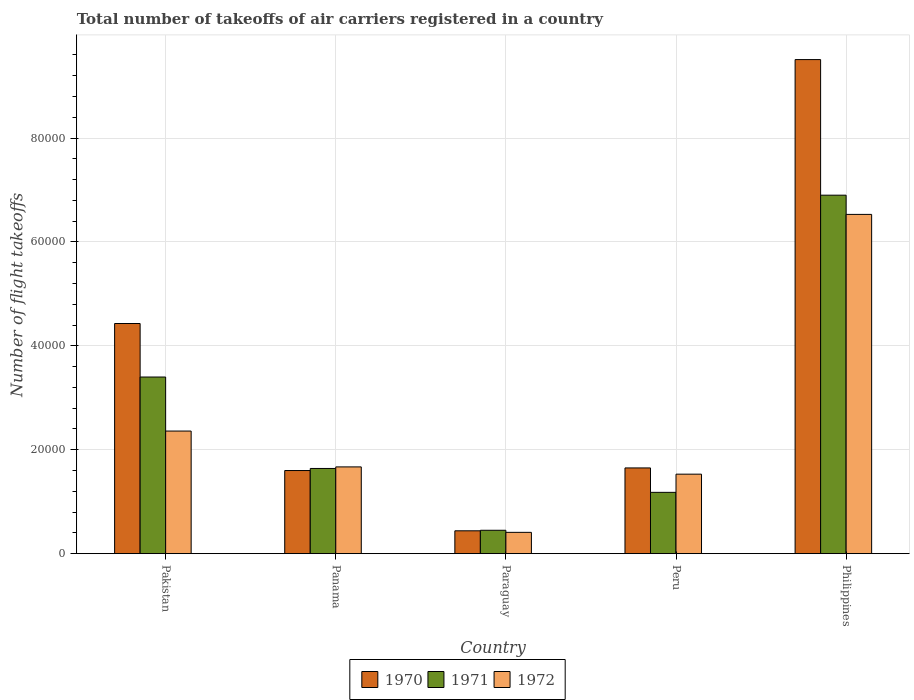How many different coloured bars are there?
Give a very brief answer. 3. How many groups of bars are there?
Your answer should be very brief. 5. Are the number of bars per tick equal to the number of legend labels?
Provide a succinct answer. Yes. How many bars are there on the 3rd tick from the left?
Give a very brief answer. 3. What is the label of the 4th group of bars from the left?
Make the answer very short. Peru. What is the total number of flight takeoffs in 1970 in Paraguay?
Give a very brief answer. 4400. Across all countries, what is the maximum total number of flight takeoffs in 1970?
Your answer should be compact. 9.51e+04. Across all countries, what is the minimum total number of flight takeoffs in 1972?
Make the answer very short. 4100. In which country was the total number of flight takeoffs in 1972 minimum?
Offer a very short reply. Paraguay. What is the total total number of flight takeoffs in 1971 in the graph?
Offer a terse response. 1.36e+05. What is the difference between the total number of flight takeoffs in 1972 in Paraguay and that in Philippines?
Make the answer very short. -6.12e+04. What is the difference between the total number of flight takeoffs in 1970 in Paraguay and the total number of flight takeoffs in 1971 in Pakistan?
Provide a succinct answer. -2.96e+04. What is the average total number of flight takeoffs in 1971 per country?
Keep it short and to the point. 2.71e+04. What is the difference between the total number of flight takeoffs of/in 1971 and total number of flight takeoffs of/in 1970 in Philippines?
Provide a short and direct response. -2.61e+04. In how many countries, is the total number of flight takeoffs in 1970 greater than 8000?
Provide a succinct answer. 4. What is the ratio of the total number of flight takeoffs in 1971 in Peru to that in Philippines?
Provide a succinct answer. 0.17. Is the total number of flight takeoffs in 1971 in Paraguay less than that in Peru?
Offer a terse response. Yes. Is the difference between the total number of flight takeoffs in 1971 in Panama and Peru greater than the difference between the total number of flight takeoffs in 1970 in Panama and Peru?
Give a very brief answer. Yes. What is the difference between the highest and the second highest total number of flight takeoffs in 1970?
Provide a short and direct response. -7.86e+04. What is the difference between the highest and the lowest total number of flight takeoffs in 1972?
Your response must be concise. 6.12e+04. In how many countries, is the total number of flight takeoffs in 1972 greater than the average total number of flight takeoffs in 1972 taken over all countries?
Provide a succinct answer. 1. How many bars are there?
Your answer should be compact. 15. Are all the bars in the graph horizontal?
Your answer should be very brief. No. What is the difference between two consecutive major ticks on the Y-axis?
Keep it short and to the point. 2.00e+04. Are the values on the major ticks of Y-axis written in scientific E-notation?
Offer a terse response. No. Does the graph contain grids?
Your response must be concise. Yes. How are the legend labels stacked?
Keep it short and to the point. Horizontal. What is the title of the graph?
Give a very brief answer. Total number of takeoffs of air carriers registered in a country. What is the label or title of the X-axis?
Ensure brevity in your answer.  Country. What is the label or title of the Y-axis?
Your response must be concise. Number of flight takeoffs. What is the Number of flight takeoffs in 1970 in Pakistan?
Your answer should be compact. 4.43e+04. What is the Number of flight takeoffs of 1971 in Pakistan?
Make the answer very short. 3.40e+04. What is the Number of flight takeoffs in 1972 in Pakistan?
Provide a succinct answer. 2.36e+04. What is the Number of flight takeoffs in 1970 in Panama?
Keep it short and to the point. 1.60e+04. What is the Number of flight takeoffs in 1971 in Panama?
Provide a short and direct response. 1.64e+04. What is the Number of flight takeoffs of 1972 in Panama?
Your answer should be compact. 1.67e+04. What is the Number of flight takeoffs in 1970 in Paraguay?
Offer a terse response. 4400. What is the Number of flight takeoffs in 1971 in Paraguay?
Offer a very short reply. 4500. What is the Number of flight takeoffs in 1972 in Paraguay?
Give a very brief answer. 4100. What is the Number of flight takeoffs in 1970 in Peru?
Keep it short and to the point. 1.65e+04. What is the Number of flight takeoffs of 1971 in Peru?
Give a very brief answer. 1.18e+04. What is the Number of flight takeoffs in 1972 in Peru?
Ensure brevity in your answer.  1.53e+04. What is the Number of flight takeoffs in 1970 in Philippines?
Your response must be concise. 9.51e+04. What is the Number of flight takeoffs of 1971 in Philippines?
Offer a very short reply. 6.90e+04. What is the Number of flight takeoffs of 1972 in Philippines?
Your answer should be compact. 6.53e+04. Across all countries, what is the maximum Number of flight takeoffs of 1970?
Offer a very short reply. 9.51e+04. Across all countries, what is the maximum Number of flight takeoffs of 1971?
Ensure brevity in your answer.  6.90e+04. Across all countries, what is the maximum Number of flight takeoffs in 1972?
Provide a succinct answer. 6.53e+04. Across all countries, what is the minimum Number of flight takeoffs of 1970?
Your answer should be compact. 4400. Across all countries, what is the minimum Number of flight takeoffs of 1971?
Your answer should be very brief. 4500. Across all countries, what is the minimum Number of flight takeoffs in 1972?
Give a very brief answer. 4100. What is the total Number of flight takeoffs of 1970 in the graph?
Provide a short and direct response. 1.76e+05. What is the total Number of flight takeoffs in 1971 in the graph?
Give a very brief answer. 1.36e+05. What is the total Number of flight takeoffs of 1972 in the graph?
Provide a succinct answer. 1.25e+05. What is the difference between the Number of flight takeoffs of 1970 in Pakistan and that in Panama?
Ensure brevity in your answer.  2.83e+04. What is the difference between the Number of flight takeoffs in 1971 in Pakistan and that in Panama?
Offer a very short reply. 1.76e+04. What is the difference between the Number of flight takeoffs in 1972 in Pakistan and that in Panama?
Your response must be concise. 6900. What is the difference between the Number of flight takeoffs of 1970 in Pakistan and that in Paraguay?
Your answer should be compact. 3.99e+04. What is the difference between the Number of flight takeoffs of 1971 in Pakistan and that in Paraguay?
Provide a short and direct response. 2.95e+04. What is the difference between the Number of flight takeoffs in 1972 in Pakistan and that in Paraguay?
Your answer should be compact. 1.95e+04. What is the difference between the Number of flight takeoffs of 1970 in Pakistan and that in Peru?
Offer a terse response. 2.78e+04. What is the difference between the Number of flight takeoffs in 1971 in Pakistan and that in Peru?
Provide a short and direct response. 2.22e+04. What is the difference between the Number of flight takeoffs of 1972 in Pakistan and that in Peru?
Offer a terse response. 8300. What is the difference between the Number of flight takeoffs of 1970 in Pakistan and that in Philippines?
Your answer should be compact. -5.08e+04. What is the difference between the Number of flight takeoffs of 1971 in Pakistan and that in Philippines?
Provide a succinct answer. -3.50e+04. What is the difference between the Number of flight takeoffs in 1972 in Pakistan and that in Philippines?
Offer a very short reply. -4.17e+04. What is the difference between the Number of flight takeoffs in 1970 in Panama and that in Paraguay?
Your answer should be compact. 1.16e+04. What is the difference between the Number of flight takeoffs in 1971 in Panama and that in Paraguay?
Provide a succinct answer. 1.19e+04. What is the difference between the Number of flight takeoffs of 1972 in Panama and that in Paraguay?
Make the answer very short. 1.26e+04. What is the difference between the Number of flight takeoffs of 1970 in Panama and that in Peru?
Provide a succinct answer. -500. What is the difference between the Number of flight takeoffs in 1971 in Panama and that in Peru?
Keep it short and to the point. 4600. What is the difference between the Number of flight takeoffs in 1972 in Panama and that in Peru?
Your answer should be very brief. 1400. What is the difference between the Number of flight takeoffs in 1970 in Panama and that in Philippines?
Give a very brief answer. -7.91e+04. What is the difference between the Number of flight takeoffs in 1971 in Panama and that in Philippines?
Your answer should be very brief. -5.26e+04. What is the difference between the Number of flight takeoffs in 1972 in Panama and that in Philippines?
Ensure brevity in your answer.  -4.86e+04. What is the difference between the Number of flight takeoffs in 1970 in Paraguay and that in Peru?
Make the answer very short. -1.21e+04. What is the difference between the Number of flight takeoffs of 1971 in Paraguay and that in Peru?
Provide a short and direct response. -7300. What is the difference between the Number of flight takeoffs of 1972 in Paraguay and that in Peru?
Keep it short and to the point. -1.12e+04. What is the difference between the Number of flight takeoffs in 1970 in Paraguay and that in Philippines?
Give a very brief answer. -9.07e+04. What is the difference between the Number of flight takeoffs in 1971 in Paraguay and that in Philippines?
Give a very brief answer. -6.45e+04. What is the difference between the Number of flight takeoffs of 1972 in Paraguay and that in Philippines?
Offer a terse response. -6.12e+04. What is the difference between the Number of flight takeoffs in 1970 in Peru and that in Philippines?
Your answer should be very brief. -7.86e+04. What is the difference between the Number of flight takeoffs in 1971 in Peru and that in Philippines?
Your answer should be compact. -5.72e+04. What is the difference between the Number of flight takeoffs in 1970 in Pakistan and the Number of flight takeoffs in 1971 in Panama?
Keep it short and to the point. 2.79e+04. What is the difference between the Number of flight takeoffs in 1970 in Pakistan and the Number of flight takeoffs in 1972 in Panama?
Make the answer very short. 2.76e+04. What is the difference between the Number of flight takeoffs of 1971 in Pakistan and the Number of flight takeoffs of 1972 in Panama?
Your answer should be very brief. 1.73e+04. What is the difference between the Number of flight takeoffs of 1970 in Pakistan and the Number of flight takeoffs of 1971 in Paraguay?
Offer a terse response. 3.98e+04. What is the difference between the Number of flight takeoffs of 1970 in Pakistan and the Number of flight takeoffs of 1972 in Paraguay?
Ensure brevity in your answer.  4.02e+04. What is the difference between the Number of flight takeoffs in 1971 in Pakistan and the Number of flight takeoffs in 1972 in Paraguay?
Your response must be concise. 2.99e+04. What is the difference between the Number of flight takeoffs of 1970 in Pakistan and the Number of flight takeoffs of 1971 in Peru?
Your answer should be compact. 3.25e+04. What is the difference between the Number of flight takeoffs of 1970 in Pakistan and the Number of flight takeoffs of 1972 in Peru?
Make the answer very short. 2.90e+04. What is the difference between the Number of flight takeoffs of 1971 in Pakistan and the Number of flight takeoffs of 1972 in Peru?
Keep it short and to the point. 1.87e+04. What is the difference between the Number of flight takeoffs in 1970 in Pakistan and the Number of flight takeoffs in 1971 in Philippines?
Give a very brief answer. -2.47e+04. What is the difference between the Number of flight takeoffs in 1970 in Pakistan and the Number of flight takeoffs in 1972 in Philippines?
Provide a short and direct response. -2.10e+04. What is the difference between the Number of flight takeoffs in 1971 in Pakistan and the Number of flight takeoffs in 1972 in Philippines?
Provide a short and direct response. -3.13e+04. What is the difference between the Number of flight takeoffs of 1970 in Panama and the Number of flight takeoffs of 1971 in Paraguay?
Give a very brief answer. 1.15e+04. What is the difference between the Number of flight takeoffs in 1970 in Panama and the Number of flight takeoffs in 1972 in Paraguay?
Provide a short and direct response. 1.19e+04. What is the difference between the Number of flight takeoffs of 1971 in Panama and the Number of flight takeoffs of 1972 in Paraguay?
Give a very brief answer. 1.23e+04. What is the difference between the Number of flight takeoffs in 1970 in Panama and the Number of flight takeoffs in 1971 in Peru?
Make the answer very short. 4200. What is the difference between the Number of flight takeoffs in 1970 in Panama and the Number of flight takeoffs in 1972 in Peru?
Your response must be concise. 700. What is the difference between the Number of flight takeoffs of 1971 in Panama and the Number of flight takeoffs of 1972 in Peru?
Offer a very short reply. 1100. What is the difference between the Number of flight takeoffs in 1970 in Panama and the Number of flight takeoffs in 1971 in Philippines?
Your answer should be compact. -5.30e+04. What is the difference between the Number of flight takeoffs of 1970 in Panama and the Number of flight takeoffs of 1972 in Philippines?
Your response must be concise. -4.93e+04. What is the difference between the Number of flight takeoffs in 1971 in Panama and the Number of flight takeoffs in 1972 in Philippines?
Offer a very short reply. -4.89e+04. What is the difference between the Number of flight takeoffs in 1970 in Paraguay and the Number of flight takeoffs in 1971 in Peru?
Make the answer very short. -7400. What is the difference between the Number of flight takeoffs in 1970 in Paraguay and the Number of flight takeoffs in 1972 in Peru?
Provide a short and direct response. -1.09e+04. What is the difference between the Number of flight takeoffs of 1971 in Paraguay and the Number of flight takeoffs of 1972 in Peru?
Your answer should be compact. -1.08e+04. What is the difference between the Number of flight takeoffs of 1970 in Paraguay and the Number of flight takeoffs of 1971 in Philippines?
Offer a very short reply. -6.46e+04. What is the difference between the Number of flight takeoffs of 1970 in Paraguay and the Number of flight takeoffs of 1972 in Philippines?
Provide a short and direct response. -6.09e+04. What is the difference between the Number of flight takeoffs in 1971 in Paraguay and the Number of flight takeoffs in 1972 in Philippines?
Your response must be concise. -6.08e+04. What is the difference between the Number of flight takeoffs of 1970 in Peru and the Number of flight takeoffs of 1971 in Philippines?
Give a very brief answer. -5.25e+04. What is the difference between the Number of flight takeoffs of 1970 in Peru and the Number of flight takeoffs of 1972 in Philippines?
Your answer should be compact. -4.88e+04. What is the difference between the Number of flight takeoffs in 1971 in Peru and the Number of flight takeoffs in 1972 in Philippines?
Offer a terse response. -5.35e+04. What is the average Number of flight takeoffs in 1970 per country?
Your answer should be very brief. 3.53e+04. What is the average Number of flight takeoffs of 1971 per country?
Offer a terse response. 2.71e+04. What is the average Number of flight takeoffs of 1972 per country?
Your answer should be very brief. 2.50e+04. What is the difference between the Number of flight takeoffs in 1970 and Number of flight takeoffs in 1971 in Pakistan?
Your answer should be very brief. 1.03e+04. What is the difference between the Number of flight takeoffs in 1970 and Number of flight takeoffs in 1972 in Pakistan?
Make the answer very short. 2.07e+04. What is the difference between the Number of flight takeoffs in 1971 and Number of flight takeoffs in 1972 in Pakistan?
Give a very brief answer. 1.04e+04. What is the difference between the Number of flight takeoffs of 1970 and Number of flight takeoffs of 1971 in Panama?
Offer a very short reply. -400. What is the difference between the Number of flight takeoffs of 1970 and Number of flight takeoffs of 1972 in Panama?
Provide a short and direct response. -700. What is the difference between the Number of flight takeoffs in 1971 and Number of flight takeoffs in 1972 in Panama?
Make the answer very short. -300. What is the difference between the Number of flight takeoffs in 1970 and Number of flight takeoffs in 1971 in Paraguay?
Offer a very short reply. -100. What is the difference between the Number of flight takeoffs of 1970 and Number of flight takeoffs of 1972 in Paraguay?
Give a very brief answer. 300. What is the difference between the Number of flight takeoffs in 1971 and Number of flight takeoffs in 1972 in Paraguay?
Make the answer very short. 400. What is the difference between the Number of flight takeoffs in 1970 and Number of flight takeoffs in 1971 in Peru?
Provide a succinct answer. 4700. What is the difference between the Number of flight takeoffs of 1970 and Number of flight takeoffs of 1972 in Peru?
Offer a terse response. 1200. What is the difference between the Number of flight takeoffs of 1971 and Number of flight takeoffs of 1972 in Peru?
Your response must be concise. -3500. What is the difference between the Number of flight takeoffs of 1970 and Number of flight takeoffs of 1971 in Philippines?
Your answer should be compact. 2.61e+04. What is the difference between the Number of flight takeoffs in 1970 and Number of flight takeoffs in 1972 in Philippines?
Keep it short and to the point. 2.98e+04. What is the difference between the Number of flight takeoffs of 1971 and Number of flight takeoffs of 1972 in Philippines?
Ensure brevity in your answer.  3700. What is the ratio of the Number of flight takeoffs in 1970 in Pakistan to that in Panama?
Make the answer very short. 2.77. What is the ratio of the Number of flight takeoffs of 1971 in Pakistan to that in Panama?
Your answer should be very brief. 2.07. What is the ratio of the Number of flight takeoffs of 1972 in Pakistan to that in Panama?
Offer a very short reply. 1.41. What is the ratio of the Number of flight takeoffs in 1970 in Pakistan to that in Paraguay?
Give a very brief answer. 10.07. What is the ratio of the Number of flight takeoffs in 1971 in Pakistan to that in Paraguay?
Your answer should be very brief. 7.56. What is the ratio of the Number of flight takeoffs of 1972 in Pakistan to that in Paraguay?
Offer a terse response. 5.76. What is the ratio of the Number of flight takeoffs in 1970 in Pakistan to that in Peru?
Your response must be concise. 2.68. What is the ratio of the Number of flight takeoffs of 1971 in Pakistan to that in Peru?
Provide a succinct answer. 2.88. What is the ratio of the Number of flight takeoffs of 1972 in Pakistan to that in Peru?
Your response must be concise. 1.54. What is the ratio of the Number of flight takeoffs of 1970 in Pakistan to that in Philippines?
Your answer should be very brief. 0.47. What is the ratio of the Number of flight takeoffs in 1971 in Pakistan to that in Philippines?
Offer a terse response. 0.49. What is the ratio of the Number of flight takeoffs in 1972 in Pakistan to that in Philippines?
Provide a short and direct response. 0.36. What is the ratio of the Number of flight takeoffs of 1970 in Panama to that in Paraguay?
Offer a terse response. 3.64. What is the ratio of the Number of flight takeoffs of 1971 in Panama to that in Paraguay?
Make the answer very short. 3.64. What is the ratio of the Number of flight takeoffs of 1972 in Panama to that in Paraguay?
Provide a succinct answer. 4.07. What is the ratio of the Number of flight takeoffs in 1970 in Panama to that in Peru?
Your response must be concise. 0.97. What is the ratio of the Number of flight takeoffs of 1971 in Panama to that in Peru?
Your response must be concise. 1.39. What is the ratio of the Number of flight takeoffs of 1972 in Panama to that in Peru?
Provide a short and direct response. 1.09. What is the ratio of the Number of flight takeoffs in 1970 in Panama to that in Philippines?
Your response must be concise. 0.17. What is the ratio of the Number of flight takeoffs of 1971 in Panama to that in Philippines?
Provide a short and direct response. 0.24. What is the ratio of the Number of flight takeoffs of 1972 in Panama to that in Philippines?
Your response must be concise. 0.26. What is the ratio of the Number of flight takeoffs of 1970 in Paraguay to that in Peru?
Provide a succinct answer. 0.27. What is the ratio of the Number of flight takeoffs of 1971 in Paraguay to that in Peru?
Give a very brief answer. 0.38. What is the ratio of the Number of flight takeoffs of 1972 in Paraguay to that in Peru?
Make the answer very short. 0.27. What is the ratio of the Number of flight takeoffs in 1970 in Paraguay to that in Philippines?
Give a very brief answer. 0.05. What is the ratio of the Number of flight takeoffs in 1971 in Paraguay to that in Philippines?
Your response must be concise. 0.07. What is the ratio of the Number of flight takeoffs of 1972 in Paraguay to that in Philippines?
Provide a short and direct response. 0.06. What is the ratio of the Number of flight takeoffs in 1970 in Peru to that in Philippines?
Ensure brevity in your answer.  0.17. What is the ratio of the Number of flight takeoffs of 1971 in Peru to that in Philippines?
Provide a short and direct response. 0.17. What is the ratio of the Number of flight takeoffs in 1972 in Peru to that in Philippines?
Ensure brevity in your answer.  0.23. What is the difference between the highest and the second highest Number of flight takeoffs in 1970?
Ensure brevity in your answer.  5.08e+04. What is the difference between the highest and the second highest Number of flight takeoffs of 1971?
Your answer should be compact. 3.50e+04. What is the difference between the highest and the second highest Number of flight takeoffs in 1972?
Your answer should be compact. 4.17e+04. What is the difference between the highest and the lowest Number of flight takeoffs in 1970?
Make the answer very short. 9.07e+04. What is the difference between the highest and the lowest Number of flight takeoffs of 1971?
Provide a succinct answer. 6.45e+04. What is the difference between the highest and the lowest Number of flight takeoffs in 1972?
Provide a short and direct response. 6.12e+04. 